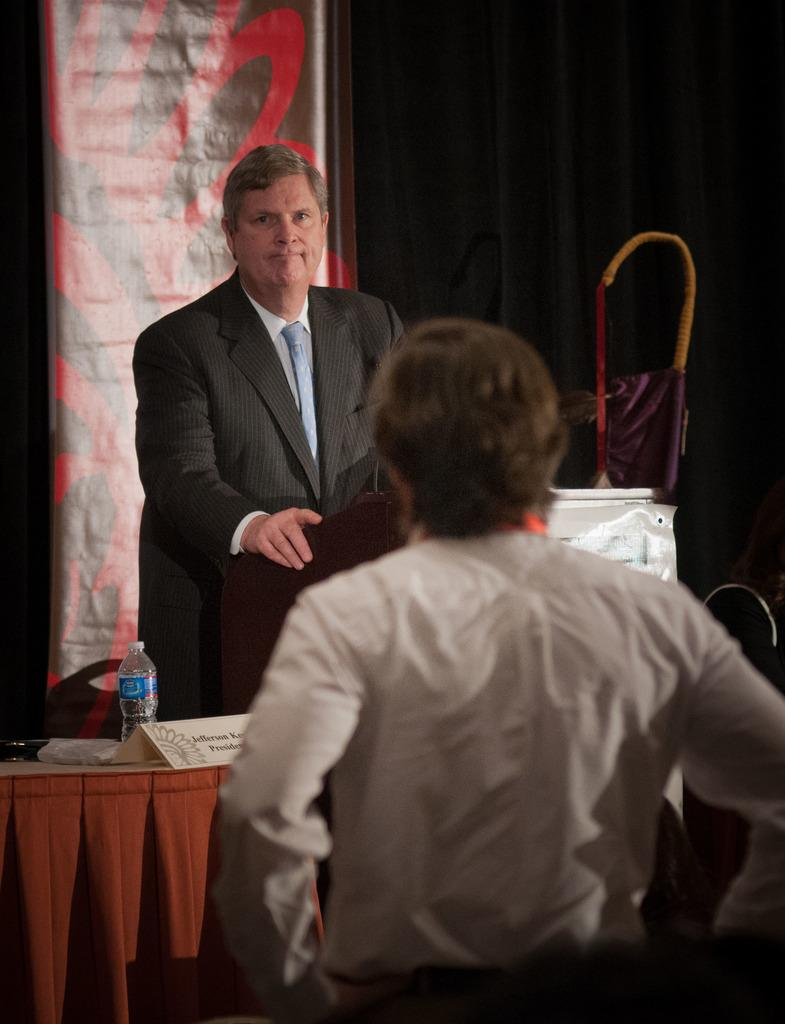How many people are present in the image? There are two people standing in the image. What can be seen in the image besides the people? There is a table in the image. What is on the table? There are objects on the table. Where are additional objects located in the image? There are objects on the right side of the image. What type of hill can be seen in the background of the image? There is no hill visible in the image; it only shows two people, a table, and objects on the right side. 